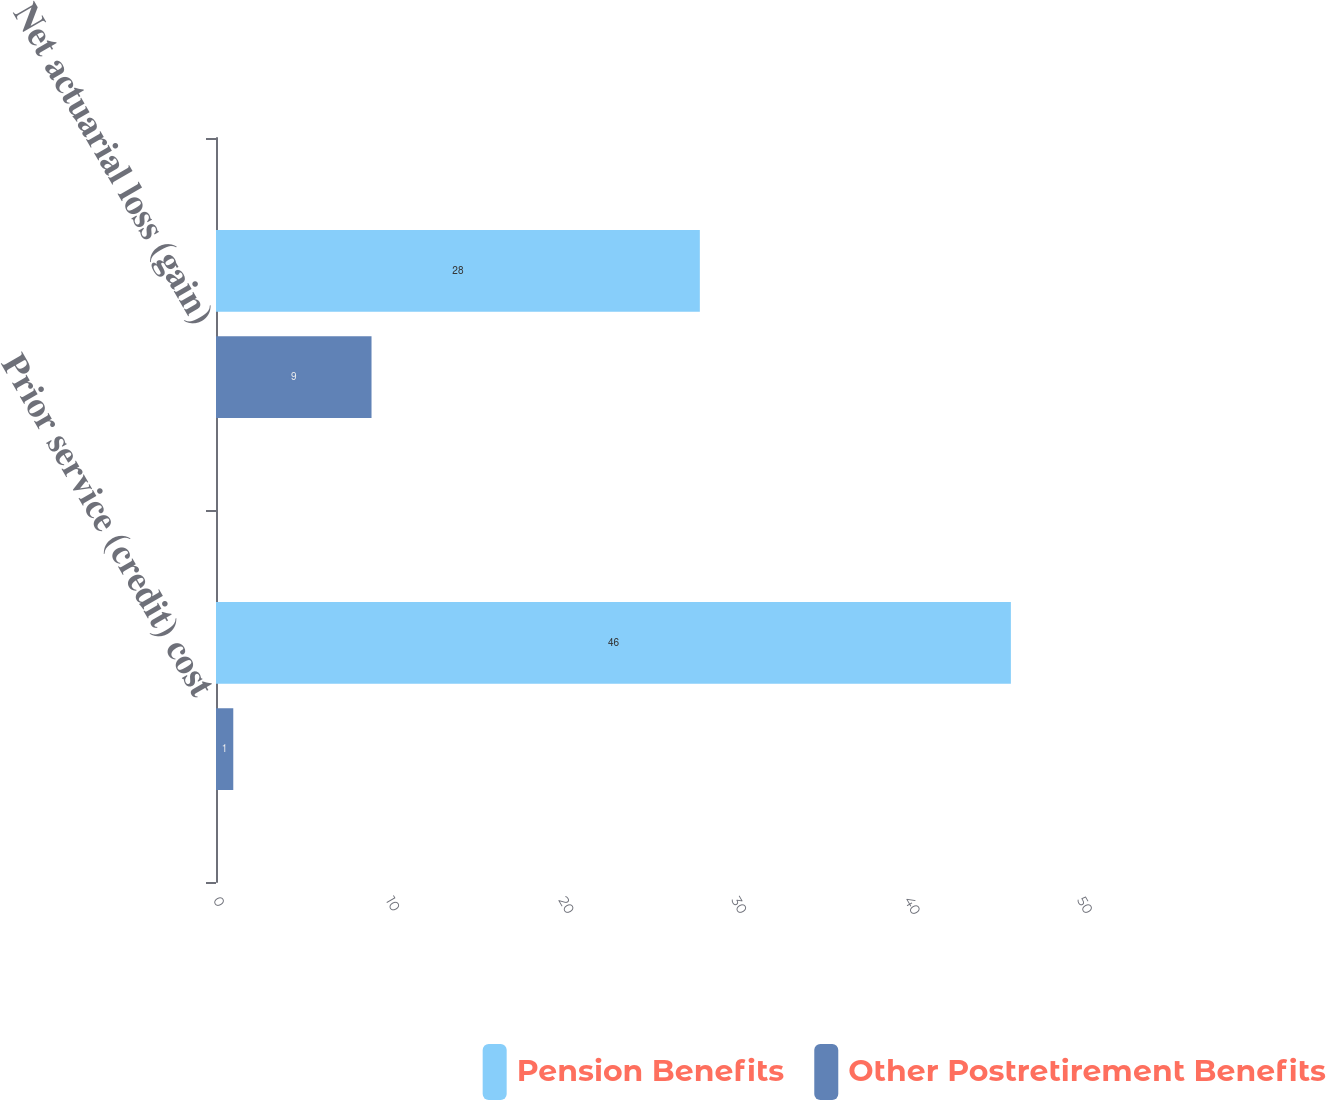<chart> <loc_0><loc_0><loc_500><loc_500><stacked_bar_chart><ecel><fcel>Prior service (credit) cost<fcel>Net actuarial loss (gain)<nl><fcel>Pension Benefits<fcel>46<fcel>28<nl><fcel>Other Postretirement Benefits<fcel>1<fcel>9<nl></chart> 